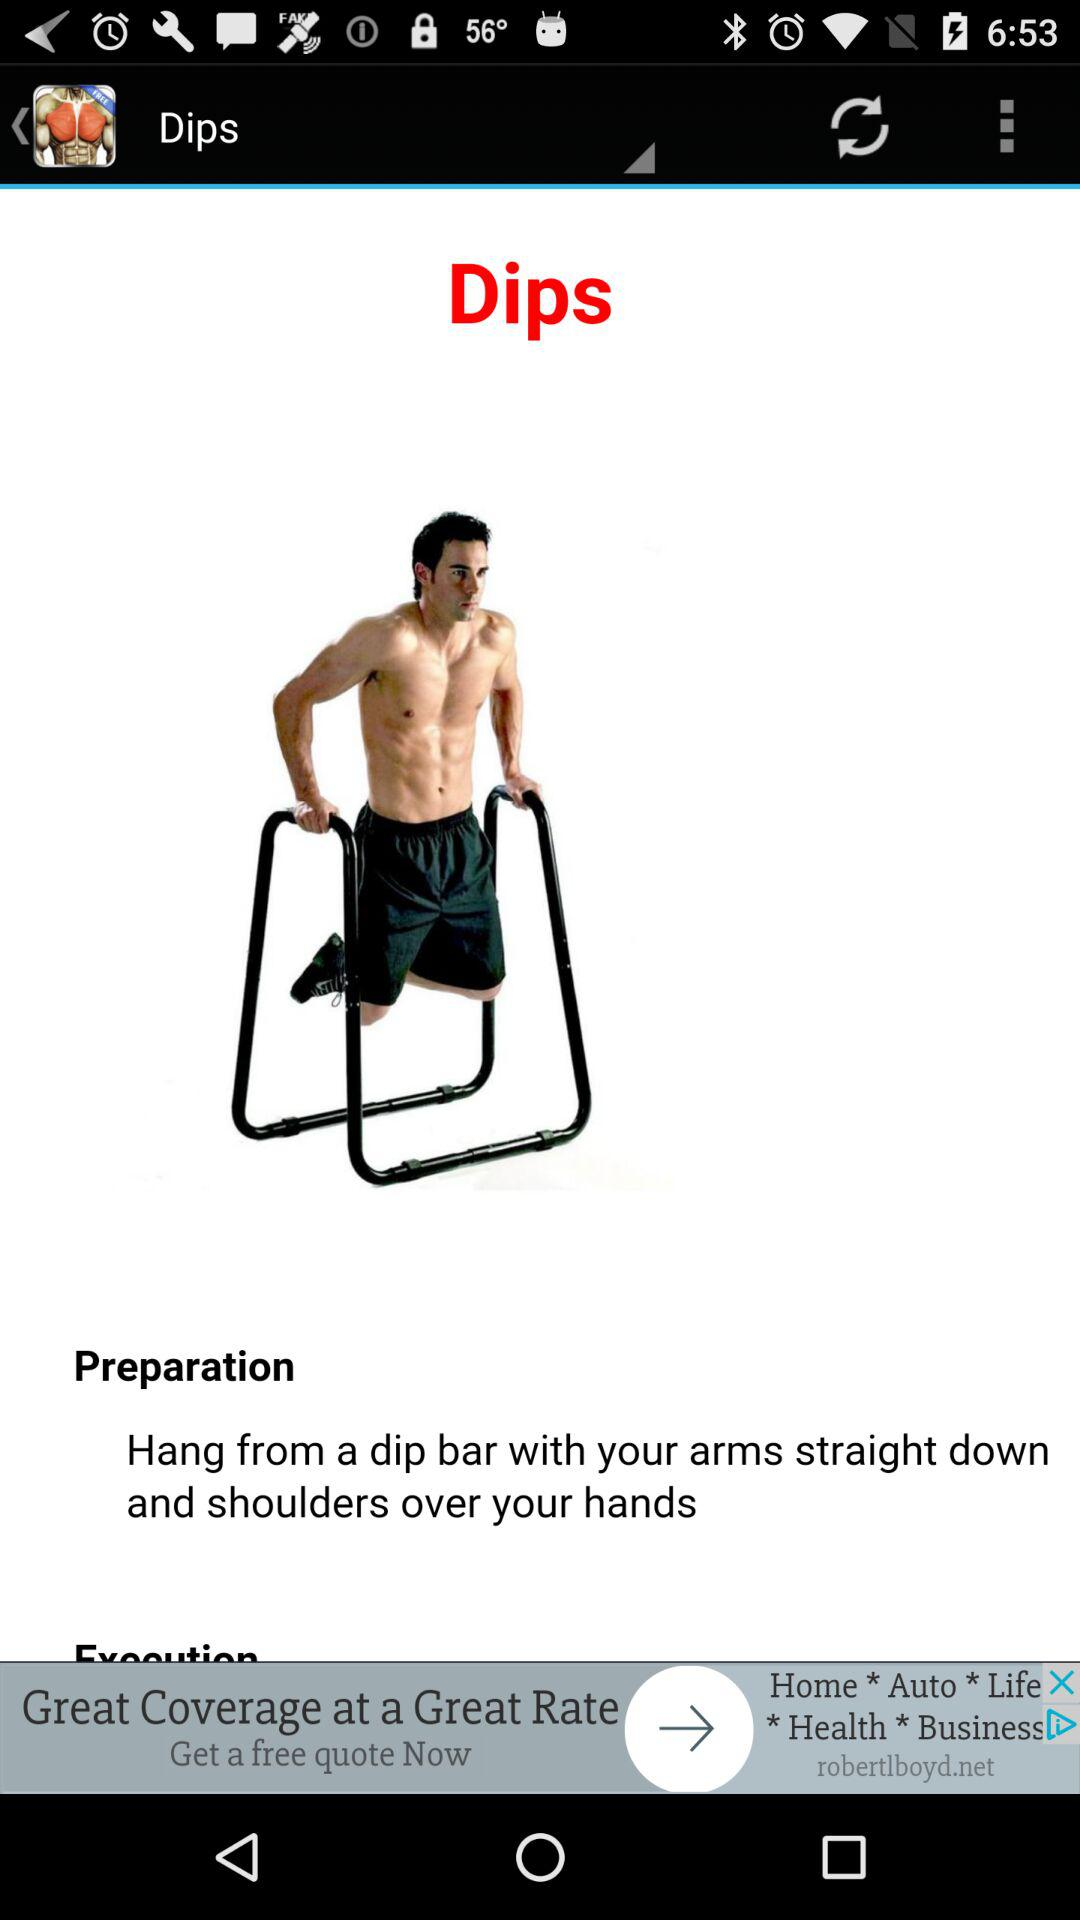What is the name of the displayed exercise? The name of the displayed exercise is dips. 